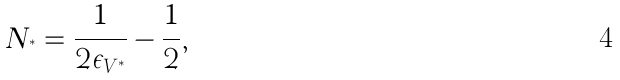<formula> <loc_0><loc_0><loc_500><loc_500>N _ { ^ { * } } = \frac { 1 } { 2 \epsilon _ { V ^ { * } } } - \frac { 1 } { 2 } ,</formula> 